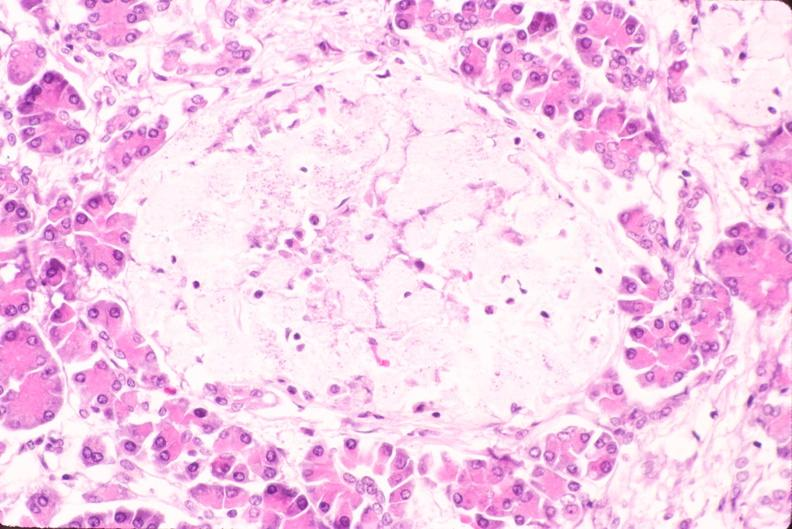does this image show pancreas, islet hyalinization, diabetes mellitus?
Answer the question using a single word or phrase. Yes 